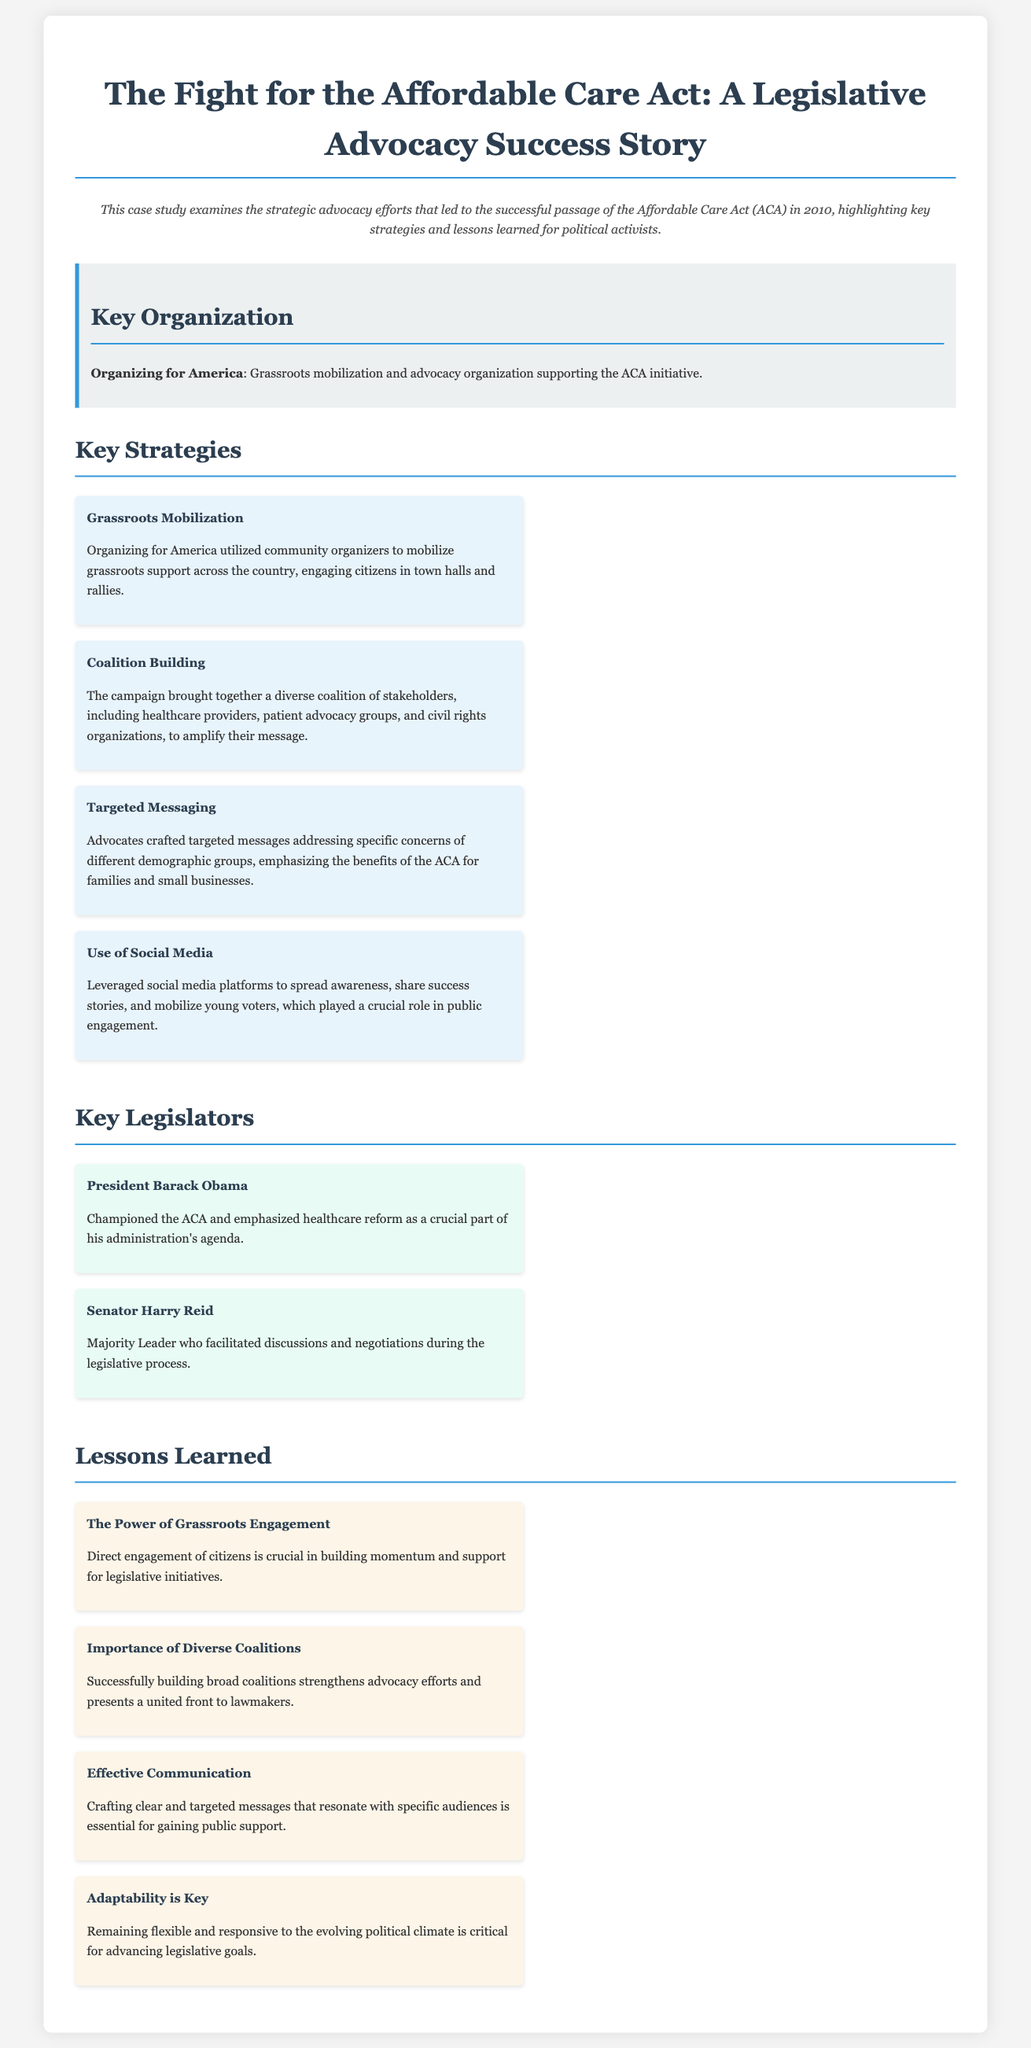what year was the Affordable Care Act passed? The document states that the Affordable Care Act was passed in 2010.
Answer: 2010 who was the key organization supporting the ACA initiative? The document identifies "Organizing for America" as the key organization supporting the ACA initiative.
Answer: Organizing for America name one strategy used in the advocacy efforts. The document lists several strategies, one of them is "Grassroots Mobilization".
Answer: Grassroots Mobilization which key legislator emphasized healthcare reform? According to the document, President Barack Obama emphasized healthcare reform as a crucial part of his agenda.
Answer: President Barack Obama what is a lesson learned about communication from the case study? The document highlights that effective communication involves crafting clear and targeted messages that resonate with specific audiences.
Answer: Effective Communication how did the campaign utilize social media? The document notes that the campaign leveraged social media platforms to spread awareness and mobilize young voters.
Answer: Spread awareness and mobilize young voters what is the importance of diverse coalitions? The document explains that building broad coalitions strengthens advocacy efforts and presents a united front to lawmakers.
Answer: Strengthens advocacy efforts who was the Majority Leader during the legislative process? The document names Senator Harry Reid as the Majority Leader who facilitated discussions during the legislative process.
Answer: Senator Harry Reid 